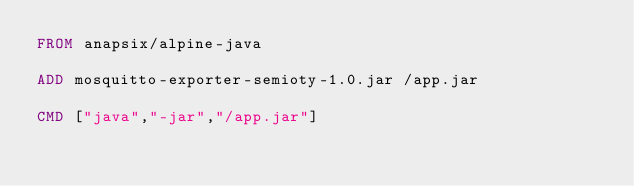<code> <loc_0><loc_0><loc_500><loc_500><_Dockerfile_>FROM anapsix/alpine-java 

ADD mosquitto-exporter-semioty-1.0.jar /app.jar

CMD ["java","-jar","/app.jar"]

</code> 